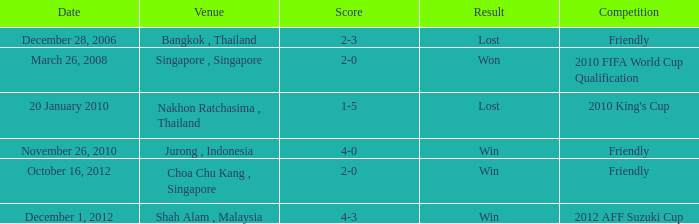What is the date when the score was 1-5? 20 January 2010. 